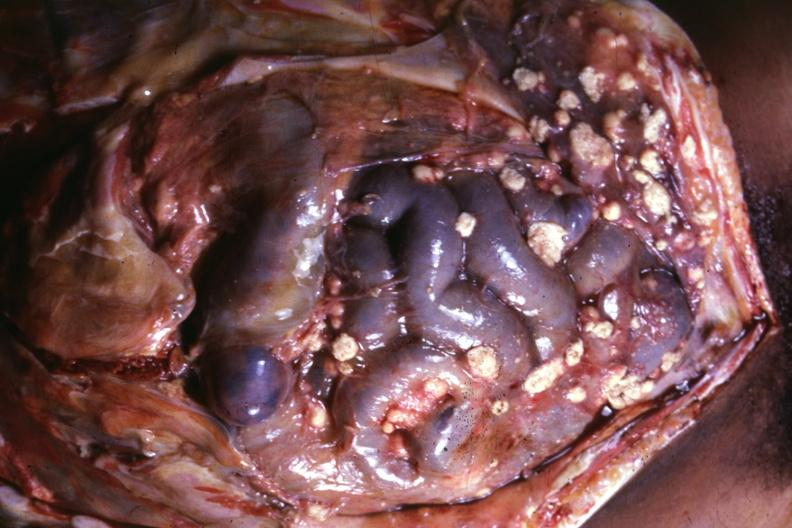what is present?
Answer the question using a single word or phrase. Peritoneum 